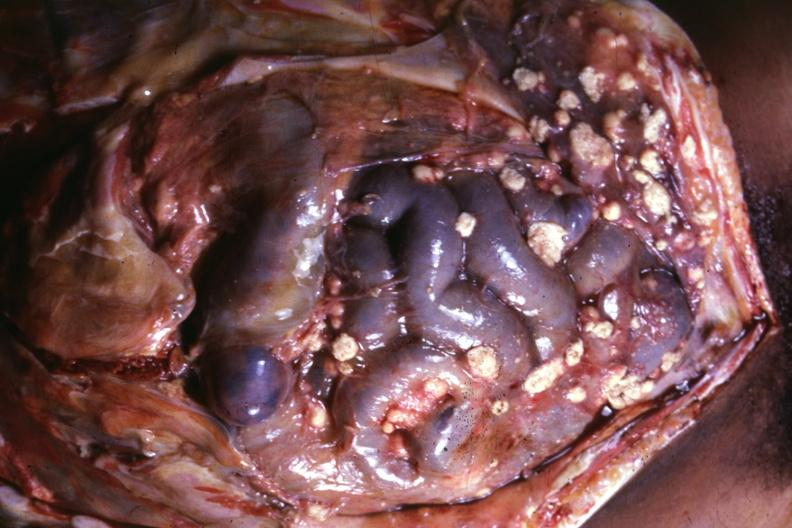what is present?
Answer the question using a single word or phrase. Peritoneum 